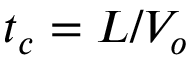<formula> <loc_0><loc_0><loc_500><loc_500>t _ { c } = L / V _ { o }</formula> 